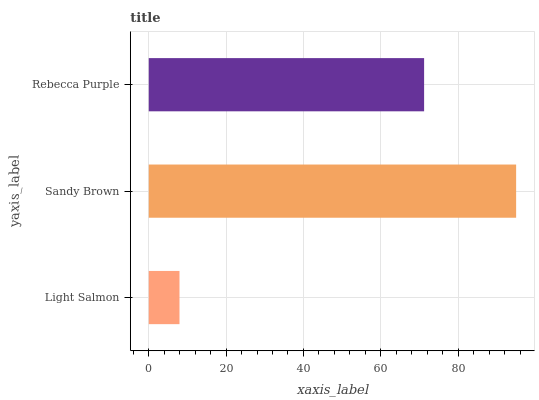Is Light Salmon the minimum?
Answer yes or no. Yes. Is Sandy Brown the maximum?
Answer yes or no. Yes. Is Rebecca Purple the minimum?
Answer yes or no. No. Is Rebecca Purple the maximum?
Answer yes or no. No. Is Sandy Brown greater than Rebecca Purple?
Answer yes or no. Yes. Is Rebecca Purple less than Sandy Brown?
Answer yes or no. Yes. Is Rebecca Purple greater than Sandy Brown?
Answer yes or no. No. Is Sandy Brown less than Rebecca Purple?
Answer yes or no. No. Is Rebecca Purple the high median?
Answer yes or no. Yes. Is Rebecca Purple the low median?
Answer yes or no. Yes. Is Light Salmon the high median?
Answer yes or no. No. Is Sandy Brown the low median?
Answer yes or no. No. 